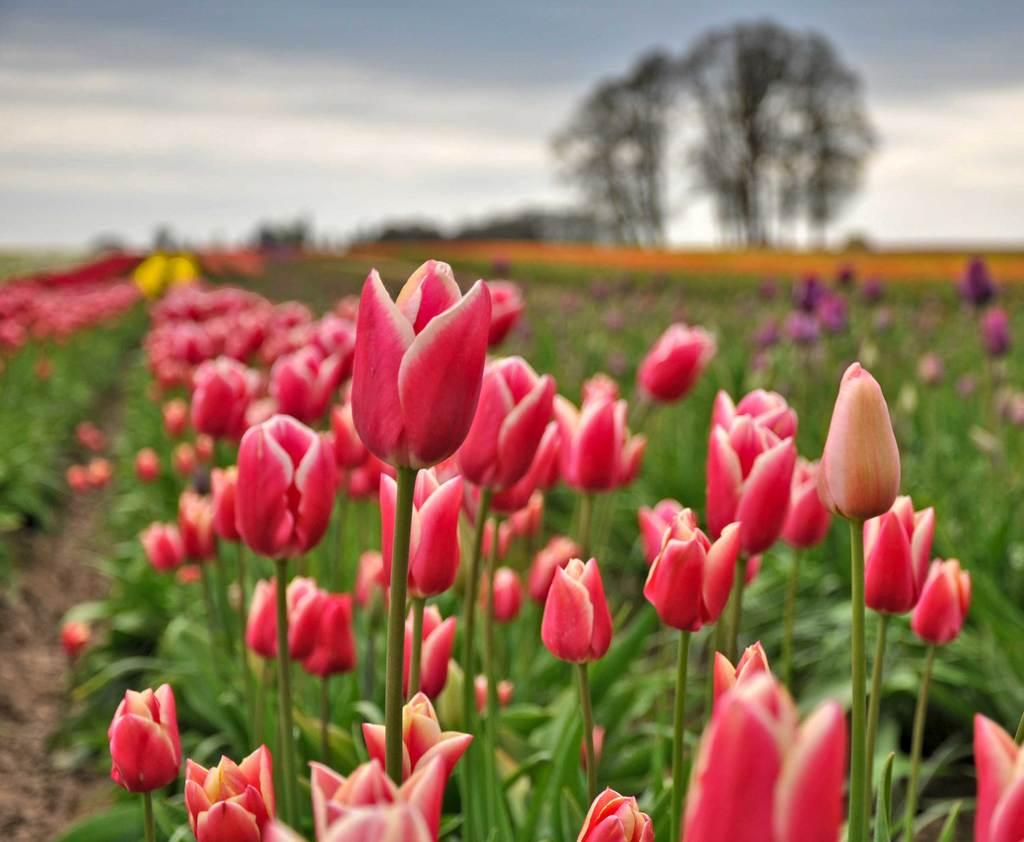What type of plants can be seen in the image? There are plants with flowers in the image. What can be seen in the background of the image? There are trees in the background of the image. What is visible at the top of the image? The sky is visible at the top of the image. What type of ball is being played with in the image? There is no ball present in the image. Can you tell me what kind of guitar is being strummed in the image? There is no guitar present in the image. 